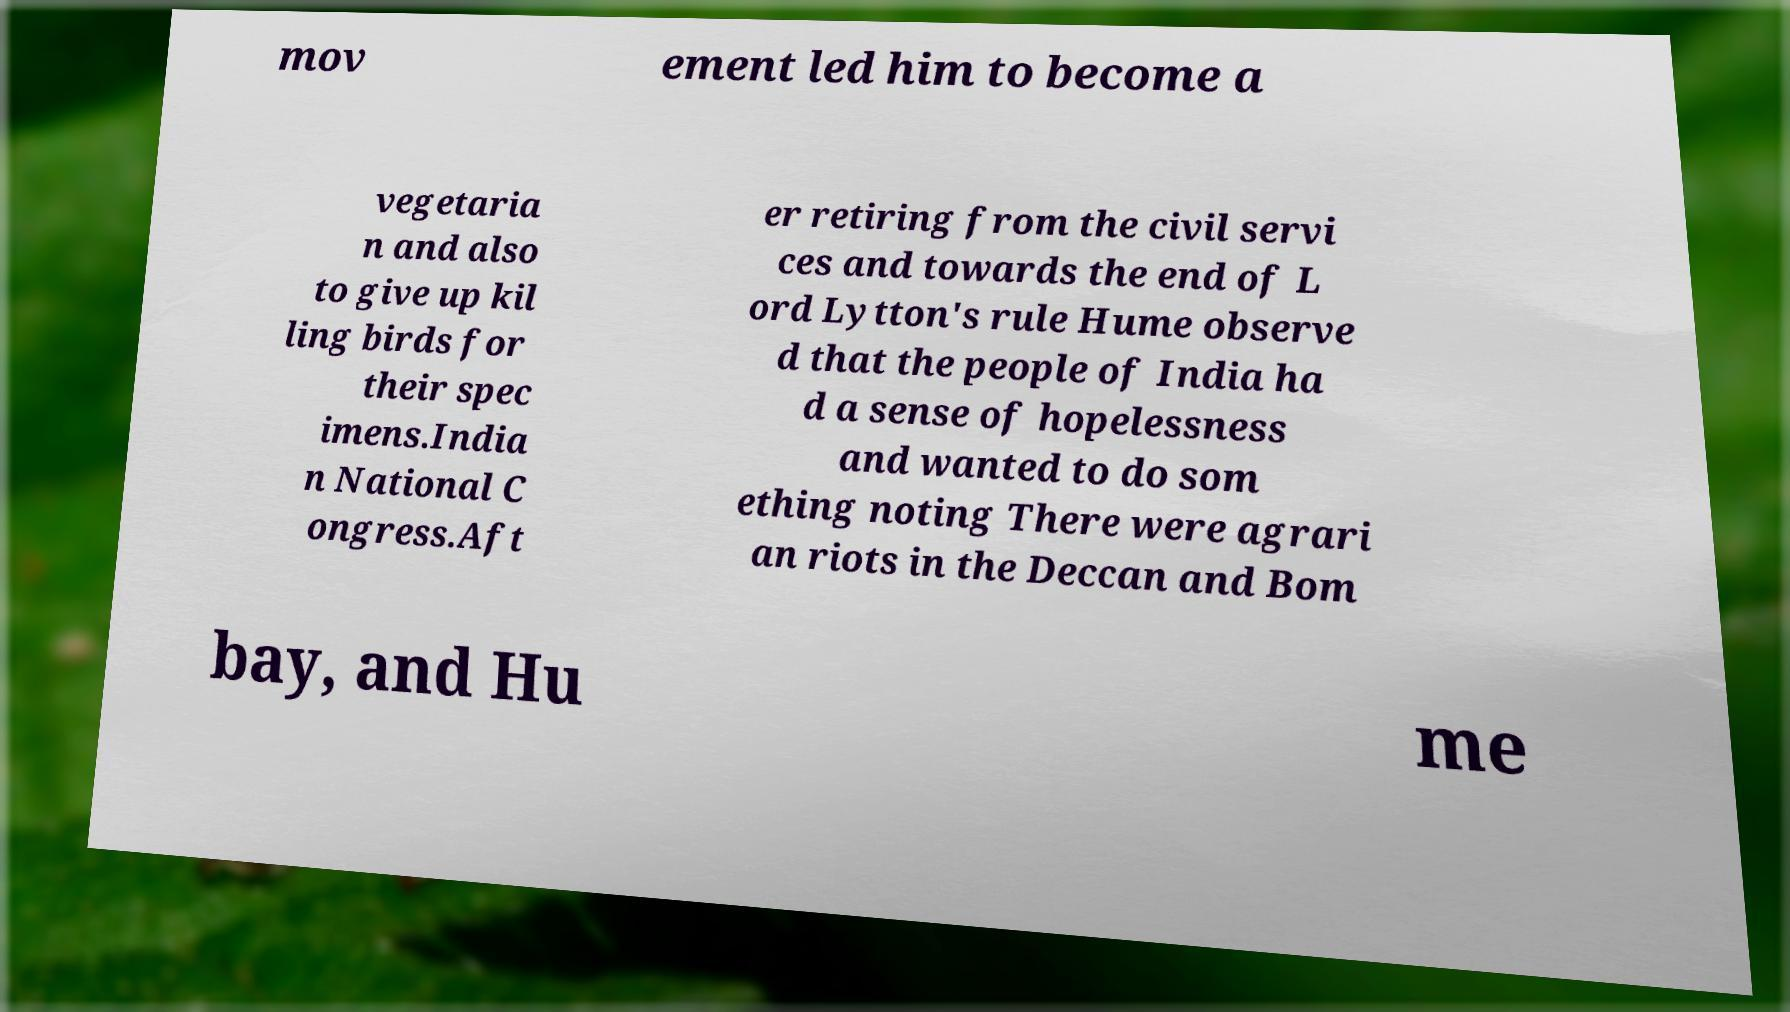Could you extract and type out the text from this image? mov ement led him to become a vegetaria n and also to give up kil ling birds for their spec imens.India n National C ongress.Aft er retiring from the civil servi ces and towards the end of L ord Lytton's rule Hume observe d that the people of India ha d a sense of hopelessness and wanted to do som ething noting There were agrari an riots in the Deccan and Bom bay, and Hu me 